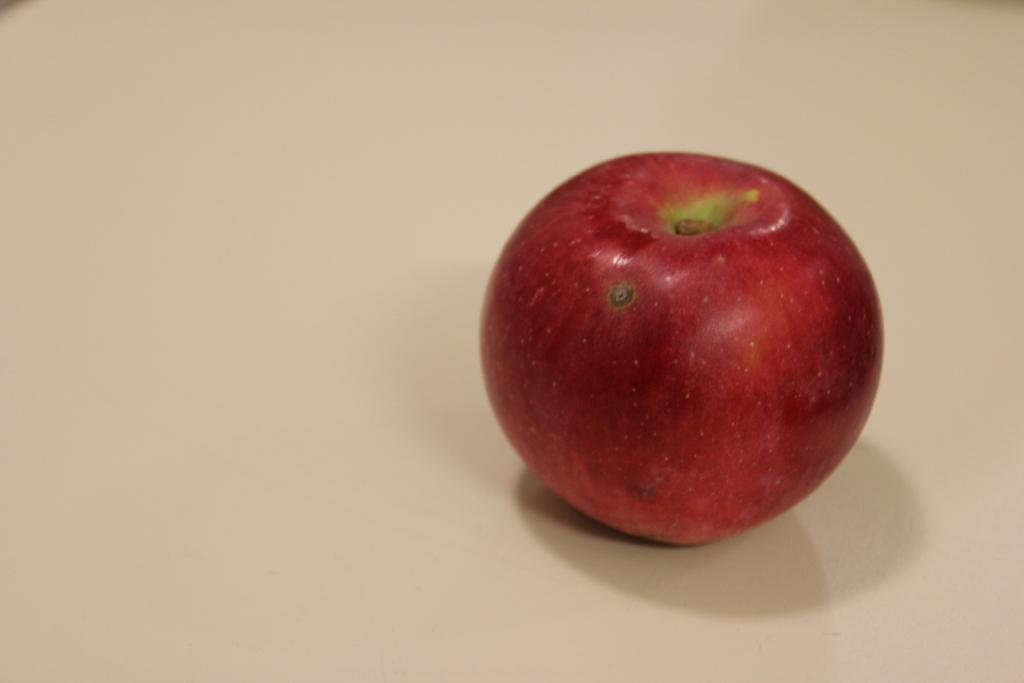How would you summarize this image in a sentence or two? In this picture, we see an apple. It might be placed on the table. In the background, it is white in color. 